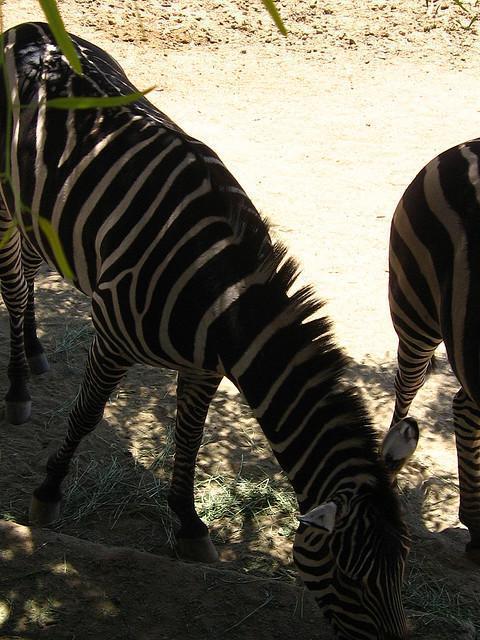How many zebras are there?
Give a very brief answer. 2. 